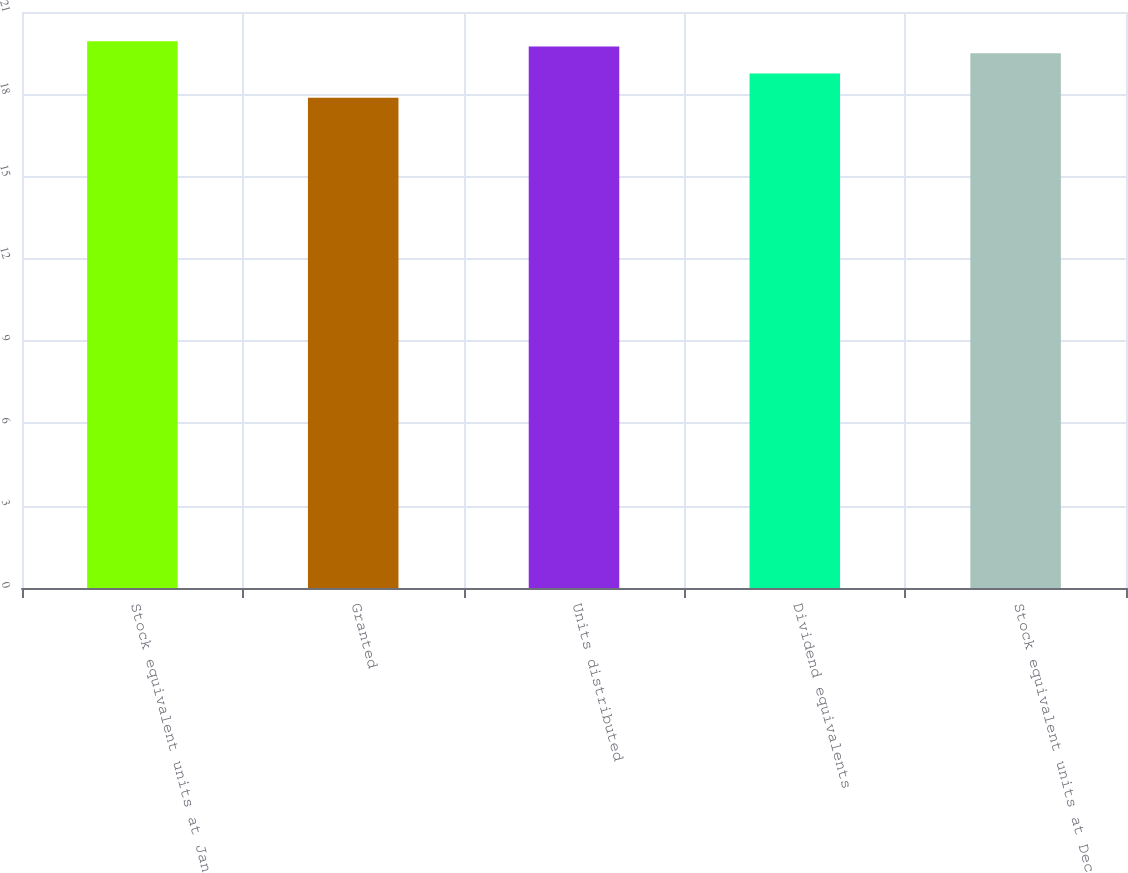Convert chart. <chart><loc_0><loc_0><loc_500><loc_500><bar_chart><fcel>Stock equivalent units at Jan<fcel>Granted<fcel>Units distributed<fcel>Dividend equivalents<fcel>Stock equivalent units at Dec<nl><fcel>19.93<fcel>17.87<fcel>19.74<fcel>18.76<fcel>19.5<nl></chart> 